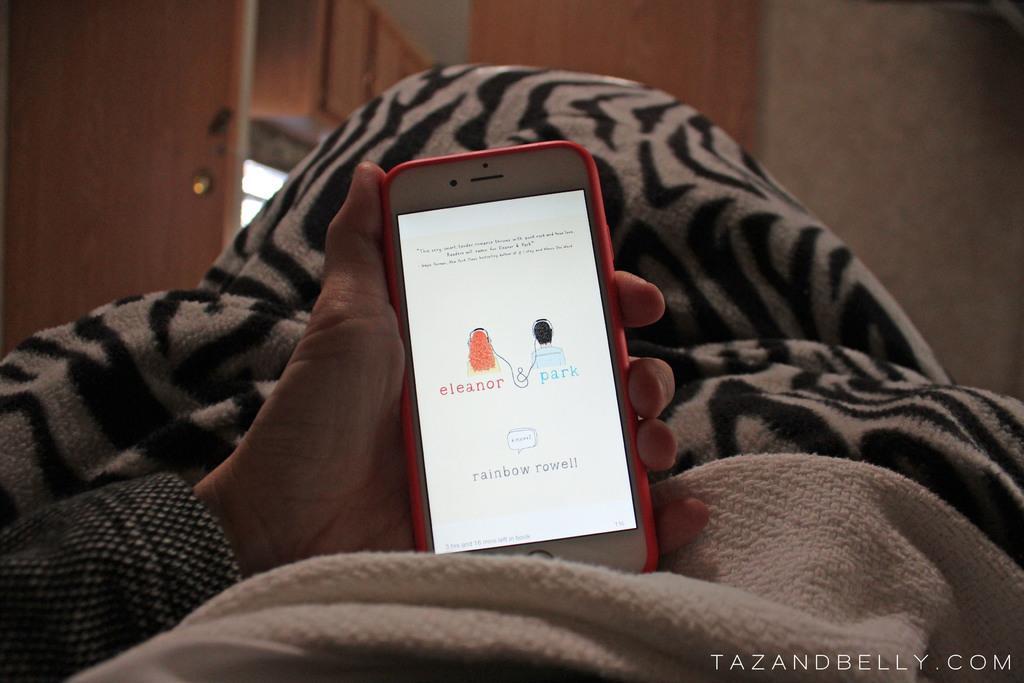In one or two sentences, can you explain what this image depicts? In this image I can see the person holding the mobile. I can see the person's hand on the bed sheets which are in cream and black color. In the background I can see the wall and the wooden door. 